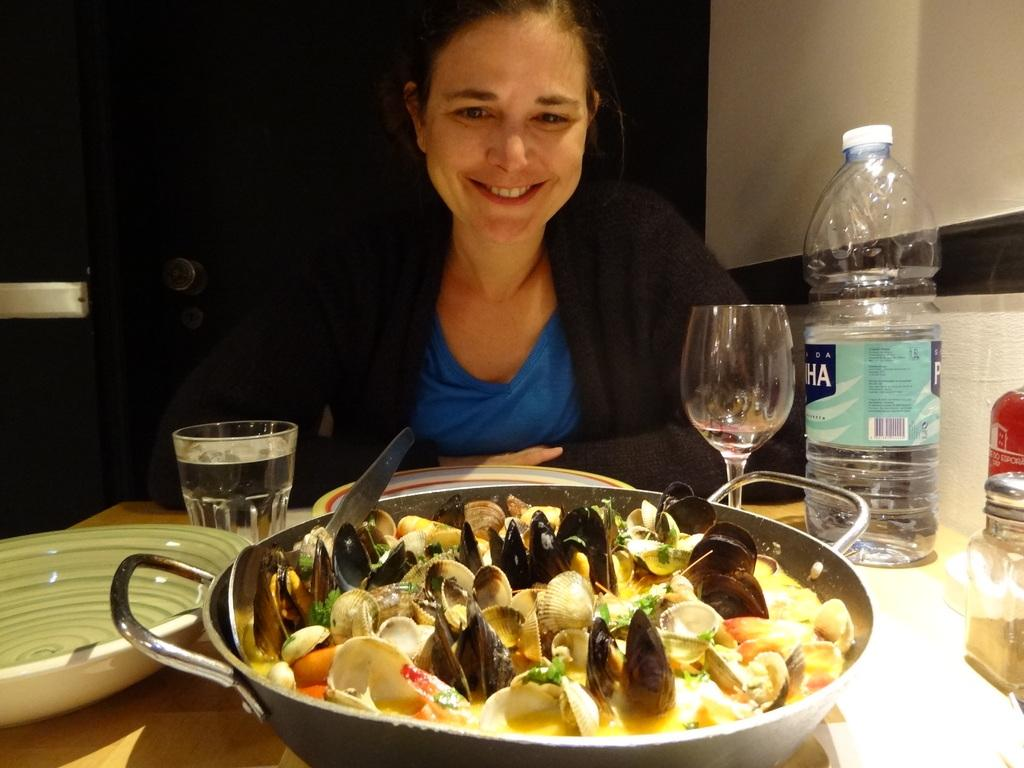What is the main subject in the foreground of the image? There is a food item in the foreground of the image. What can be seen at the right side of the image? There is a water bottle and a glass at the right side of the image. Can you describe the woman in the background of the image? There is a woman in the background of the image, and she is looking at the food. What type of insurance does the woman have for her throat in the image? There is no information about insurance or the woman's throat in the image. 